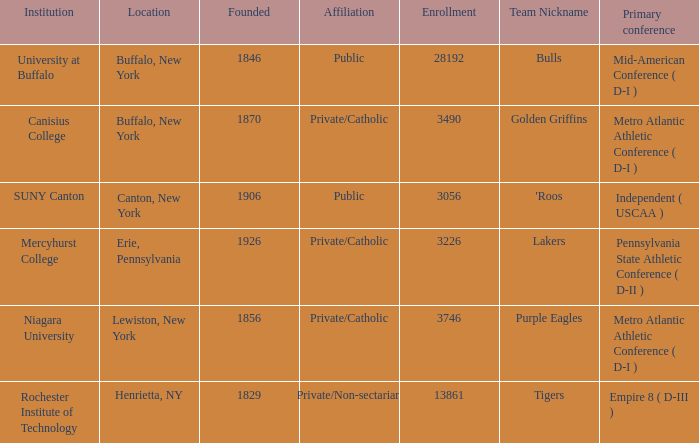Give me the full table as a dictionary. {'header': ['Institution', 'Location', 'Founded', 'Affiliation', 'Enrollment', 'Team Nickname', 'Primary conference'], 'rows': [['University at Buffalo', 'Buffalo, New York', '1846', 'Public', '28192', 'Bulls', 'Mid-American Conference ( D-I )'], ['Canisius College', 'Buffalo, New York', '1870', 'Private/Catholic', '3490', 'Golden Griffins', 'Metro Atlantic Athletic Conference ( D-I )'], ['SUNY Canton', 'Canton, New York', '1906', 'Public', '3056', "'Roos", 'Independent ( USCAA )'], ['Mercyhurst College', 'Erie, Pennsylvania', '1926', 'Private/Catholic', '3226', 'Lakers', 'Pennsylvania State Athletic Conference ( D-II )'], ['Niagara University', 'Lewiston, New York', '1856', 'Private/Catholic', '3746', 'Purple Eagles', 'Metro Atlantic Athletic Conference ( D-I )'], ['Rochester Institute of Technology', 'Henrietta, NY', '1829', 'Private/Non-sectarian', '13861', 'Tigers', 'Empire 8 ( D-III )']]} What is the nature of the school in canton, new york? Public. 